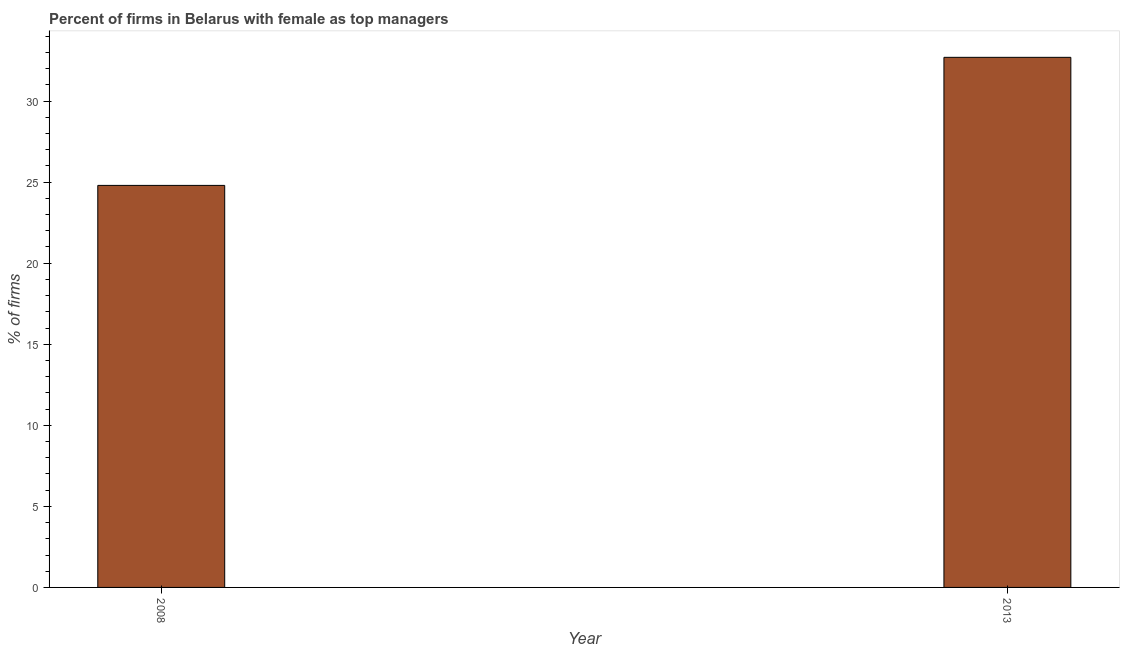What is the title of the graph?
Ensure brevity in your answer.  Percent of firms in Belarus with female as top managers. What is the label or title of the X-axis?
Your answer should be very brief. Year. What is the label or title of the Y-axis?
Provide a succinct answer. % of firms. What is the percentage of firms with female as top manager in 2008?
Keep it short and to the point. 24.8. Across all years, what is the maximum percentage of firms with female as top manager?
Your response must be concise. 32.7. Across all years, what is the minimum percentage of firms with female as top manager?
Make the answer very short. 24.8. In which year was the percentage of firms with female as top manager maximum?
Offer a terse response. 2013. What is the sum of the percentage of firms with female as top manager?
Keep it short and to the point. 57.5. What is the difference between the percentage of firms with female as top manager in 2008 and 2013?
Offer a terse response. -7.9. What is the average percentage of firms with female as top manager per year?
Offer a terse response. 28.75. What is the median percentage of firms with female as top manager?
Your response must be concise. 28.75. What is the ratio of the percentage of firms with female as top manager in 2008 to that in 2013?
Keep it short and to the point. 0.76. Are all the bars in the graph horizontal?
Make the answer very short. No. What is the % of firms in 2008?
Your response must be concise. 24.8. What is the % of firms of 2013?
Your answer should be very brief. 32.7. What is the difference between the % of firms in 2008 and 2013?
Your response must be concise. -7.9. What is the ratio of the % of firms in 2008 to that in 2013?
Ensure brevity in your answer.  0.76. 